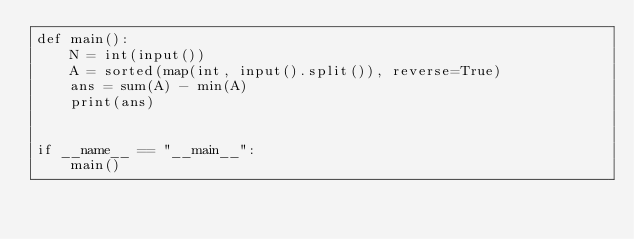Convert code to text. <code><loc_0><loc_0><loc_500><loc_500><_Python_>def main():
    N = int(input())
    A = sorted(map(int, input().split()), reverse=True)
    ans = sum(A) - min(A)
    print(ans)


if __name__ == "__main__":
    main()
</code> 